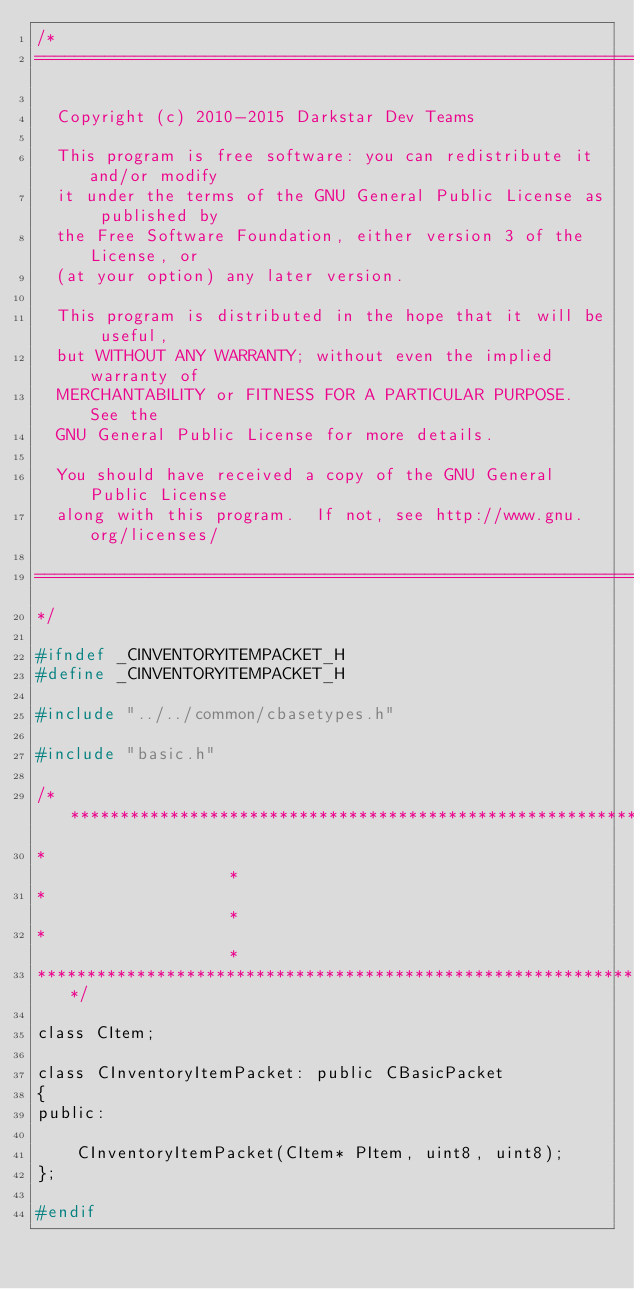Convert code to text. <code><loc_0><loc_0><loc_500><loc_500><_C_>/*
===========================================================================

  Copyright (c) 2010-2015 Darkstar Dev Teams

  This program is free software: you can redistribute it and/or modify
  it under the terms of the GNU General Public License as published by
  the Free Software Foundation, either version 3 of the License, or
  (at your option) any later version.

  This program is distributed in the hope that it will be useful,
  but WITHOUT ANY WARRANTY; without even the implied warranty of
  MERCHANTABILITY or FITNESS FOR A PARTICULAR PURPOSE.  See the
  GNU General Public License for more details.

  You should have received a copy of the GNU General Public License
  along with this program.  If not, see http://www.gnu.org/licenses/

===========================================================================
*/

#ifndef _CINVENTORYITEMPACKET_H
#define _CINVENTORYITEMPACKET_H

#include "../../common/cbasetypes.h"

#include "basic.h"

/************************************************************************
*																		*
*  																		*
*																		*
************************************************************************/

class CItem;

class CInventoryItemPacket: public CBasicPacket
{
public:

	CInventoryItemPacket(CItem* PItem, uint8, uint8);
};

#endif</code> 